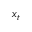<formula> <loc_0><loc_0><loc_500><loc_500>x _ { t }</formula> 